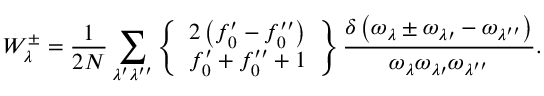Convert formula to latex. <formula><loc_0><loc_0><loc_500><loc_500>W _ { \lambda } ^ { \pm } = \frac { 1 } { 2 N } \sum _ { \lambda ^ { \prime } \lambda ^ { \prime \prime } } \left \{ \begin{array} { l } { 2 \left ( f _ { 0 } ^ { \prime } - f _ { 0 } ^ { \prime \prime } \right ) } \\ { f _ { 0 } ^ { \prime } + f _ { 0 } ^ { \prime \prime } + 1 } \end{array} \right \} \frac { \delta \left ( \omega _ { \lambda } \pm \omega _ { \lambda \prime } - \omega _ { \lambda ^ { \prime \prime } } \right ) } { \omega _ { \lambda } { \omega _ { \lambda \prime } } { \omega _ { \lambda ^ { \prime \prime } } } } .</formula> 